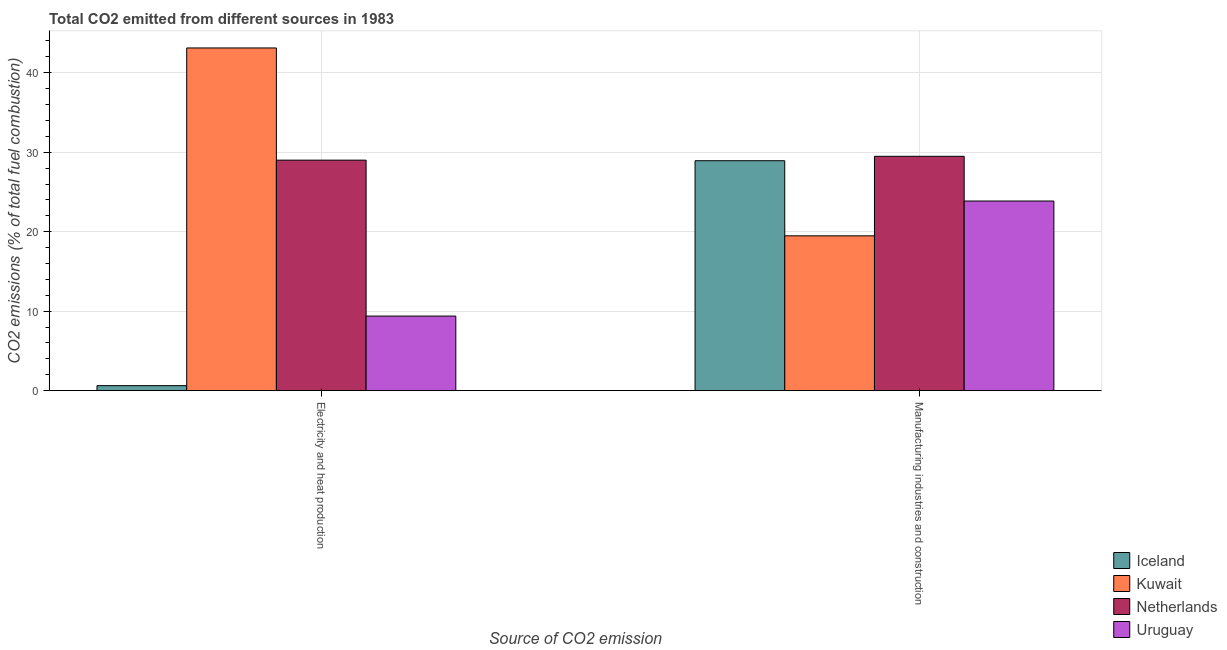Are the number of bars per tick equal to the number of legend labels?
Keep it short and to the point. Yes. Are the number of bars on each tick of the X-axis equal?
Provide a succinct answer. Yes. What is the label of the 2nd group of bars from the left?
Offer a terse response. Manufacturing industries and construction. What is the co2 emissions due to electricity and heat production in Iceland?
Offer a terse response. 0.63. Across all countries, what is the maximum co2 emissions due to manufacturing industries?
Provide a succinct answer. 29.49. Across all countries, what is the minimum co2 emissions due to manufacturing industries?
Ensure brevity in your answer.  19.48. In which country was the co2 emissions due to electricity and heat production maximum?
Your answer should be compact. Kuwait. In which country was the co2 emissions due to electricity and heat production minimum?
Keep it short and to the point. Iceland. What is the total co2 emissions due to electricity and heat production in the graph?
Provide a short and direct response. 82.13. What is the difference between the co2 emissions due to electricity and heat production in Netherlands and that in Iceland?
Ensure brevity in your answer.  28.37. What is the difference between the co2 emissions due to electricity and heat production in Kuwait and the co2 emissions due to manufacturing industries in Iceland?
Give a very brief answer. 14.19. What is the average co2 emissions due to manufacturing industries per country?
Ensure brevity in your answer.  25.44. What is the difference between the co2 emissions due to electricity and heat production and co2 emissions due to manufacturing industries in Netherlands?
Make the answer very short. -0.48. In how many countries, is the co2 emissions due to electricity and heat production greater than 4 %?
Your response must be concise. 3. What is the ratio of the co2 emissions due to electricity and heat production in Iceland to that in Netherlands?
Provide a succinct answer. 0.02. Is the co2 emissions due to manufacturing industries in Uruguay less than that in Kuwait?
Offer a very short reply. No. What does the 2nd bar from the left in Manufacturing industries and construction represents?
Your answer should be compact. Kuwait. What does the 4th bar from the right in Electricity and heat production represents?
Provide a succinct answer. Iceland. How many bars are there?
Your response must be concise. 8. How many countries are there in the graph?
Offer a very short reply. 4. Does the graph contain any zero values?
Keep it short and to the point. No. Does the graph contain grids?
Give a very brief answer. Yes. Where does the legend appear in the graph?
Offer a very short reply. Bottom right. What is the title of the graph?
Your answer should be compact. Total CO2 emitted from different sources in 1983. Does "Luxembourg" appear as one of the legend labels in the graph?
Provide a short and direct response. No. What is the label or title of the X-axis?
Make the answer very short. Source of CO2 emission. What is the label or title of the Y-axis?
Give a very brief answer. CO2 emissions (% of total fuel combustion). What is the CO2 emissions (% of total fuel combustion) of Iceland in Electricity and heat production?
Give a very brief answer. 0.63. What is the CO2 emissions (% of total fuel combustion) of Kuwait in Electricity and heat production?
Make the answer very short. 43.12. What is the CO2 emissions (% of total fuel combustion) of Netherlands in Electricity and heat production?
Make the answer very short. 29. What is the CO2 emissions (% of total fuel combustion) of Uruguay in Electricity and heat production?
Your answer should be very brief. 9.38. What is the CO2 emissions (% of total fuel combustion) of Iceland in Manufacturing industries and construction?
Your answer should be very brief. 28.93. What is the CO2 emissions (% of total fuel combustion) of Kuwait in Manufacturing industries and construction?
Ensure brevity in your answer.  19.48. What is the CO2 emissions (% of total fuel combustion) in Netherlands in Manufacturing industries and construction?
Your response must be concise. 29.49. What is the CO2 emissions (% of total fuel combustion) of Uruguay in Manufacturing industries and construction?
Provide a short and direct response. 23.86. Across all Source of CO2 emission, what is the maximum CO2 emissions (% of total fuel combustion) of Iceland?
Offer a very short reply. 28.93. Across all Source of CO2 emission, what is the maximum CO2 emissions (% of total fuel combustion) in Kuwait?
Give a very brief answer. 43.12. Across all Source of CO2 emission, what is the maximum CO2 emissions (% of total fuel combustion) in Netherlands?
Your answer should be very brief. 29.49. Across all Source of CO2 emission, what is the maximum CO2 emissions (% of total fuel combustion) of Uruguay?
Offer a very short reply. 23.86. Across all Source of CO2 emission, what is the minimum CO2 emissions (% of total fuel combustion) in Iceland?
Your answer should be very brief. 0.63. Across all Source of CO2 emission, what is the minimum CO2 emissions (% of total fuel combustion) in Kuwait?
Give a very brief answer. 19.48. Across all Source of CO2 emission, what is the minimum CO2 emissions (% of total fuel combustion) of Netherlands?
Ensure brevity in your answer.  29. Across all Source of CO2 emission, what is the minimum CO2 emissions (% of total fuel combustion) in Uruguay?
Make the answer very short. 9.38. What is the total CO2 emissions (% of total fuel combustion) in Iceland in the graph?
Make the answer very short. 29.56. What is the total CO2 emissions (% of total fuel combustion) of Kuwait in the graph?
Provide a succinct answer. 62.6. What is the total CO2 emissions (% of total fuel combustion) of Netherlands in the graph?
Provide a succinct answer. 58.49. What is the total CO2 emissions (% of total fuel combustion) in Uruguay in the graph?
Your answer should be very brief. 33.24. What is the difference between the CO2 emissions (% of total fuel combustion) of Iceland in Electricity and heat production and that in Manufacturing industries and construction?
Your answer should be very brief. -28.3. What is the difference between the CO2 emissions (% of total fuel combustion) of Kuwait in Electricity and heat production and that in Manufacturing industries and construction?
Your response must be concise. 23.64. What is the difference between the CO2 emissions (% of total fuel combustion) of Netherlands in Electricity and heat production and that in Manufacturing industries and construction?
Offer a terse response. -0.48. What is the difference between the CO2 emissions (% of total fuel combustion) in Uruguay in Electricity and heat production and that in Manufacturing industries and construction?
Provide a short and direct response. -14.48. What is the difference between the CO2 emissions (% of total fuel combustion) in Iceland in Electricity and heat production and the CO2 emissions (% of total fuel combustion) in Kuwait in Manufacturing industries and construction?
Offer a very short reply. -18.85. What is the difference between the CO2 emissions (% of total fuel combustion) of Iceland in Electricity and heat production and the CO2 emissions (% of total fuel combustion) of Netherlands in Manufacturing industries and construction?
Keep it short and to the point. -28.86. What is the difference between the CO2 emissions (% of total fuel combustion) in Iceland in Electricity and heat production and the CO2 emissions (% of total fuel combustion) in Uruguay in Manufacturing industries and construction?
Offer a terse response. -23.23. What is the difference between the CO2 emissions (% of total fuel combustion) in Kuwait in Electricity and heat production and the CO2 emissions (% of total fuel combustion) in Netherlands in Manufacturing industries and construction?
Offer a very short reply. 13.63. What is the difference between the CO2 emissions (% of total fuel combustion) of Kuwait in Electricity and heat production and the CO2 emissions (% of total fuel combustion) of Uruguay in Manufacturing industries and construction?
Provide a short and direct response. 19.26. What is the difference between the CO2 emissions (% of total fuel combustion) of Netherlands in Electricity and heat production and the CO2 emissions (% of total fuel combustion) of Uruguay in Manufacturing industries and construction?
Ensure brevity in your answer.  5.14. What is the average CO2 emissions (% of total fuel combustion) in Iceland per Source of CO2 emission?
Ensure brevity in your answer.  14.78. What is the average CO2 emissions (% of total fuel combustion) in Kuwait per Source of CO2 emission?
Make the answer very short. 31.3. What is the average CO2 emissions (% of total fuel combustion) of Netherlands per Source of CO2 emission?
Keep it short and to the point. 29.25. What is the average CO2 emissions (% of total fuel combustion) of Uruguay per Source of CO2 emission?
Your answer should be compact. 16.62. What is the difference between the CO2 emissions (% of total fuel combustion) in Iceland and CO2 emissions (% of total fuel combustion) in Kuwait in Electricity and heat production?
Your answer should be very brief. -42.49. What is the difference between the CO2 emissions (% of total fuel combustion) in Iceland and CO2 emissions (% of total fuel combustion) in Netherlands in Electricity and heat production?
Offer a terse response. -28.37. What is the difference between the CO2 emissions (% of total fuel combustion) in Iceland and CO2 emissions (% of total fuel combustion) in Uruguay in Electricity and heat production?
Give a very brief answer. -8.75. What is the difference between the CO2 emissions (% of total fuel combustion) of Kuwait and CO2 emissions (% of total fuel combustion) of Netherlands in Electricity and heat production?
Your answer should be compact. 14.12. What is the difference between the CO2 emissions (% of total fuel combustion) of Kuwait and CO2 emissions (% of total fuel combustion) of Uruguay in Electricity and heat production?
Give a very brief answer. 33.74. What is the difference between the CO2 emissions (% of total fuel combustion) of Netherlands and CO2 emissions (% of total fuel combustion) of Uruguay in Electricity and heat production?
Keep it short and to the point. 19.62. What is the difference between the CO2 emissions (% of total fuel combustion) in Iceland and CO2 emissions (% of total fuel combustion) in Kuwait in Manufacturing industries and construction?
Keep it short and to the point. 9.45. What is the difference between the CO2 emissions (% of total fuel combustion) in Iceland and CO2 emissions (% of total fuel combustion) in Netherlands in Manufacturing industries and construction?
Your answer should be very brief. -0.56. What is the difference between the CO2 emissions (% of total fuel combustion) of Iceland and CO2 emissions (% of total fuel combustion) of Uruguay in Manufacturing industries and construction?
Provide a succinct answer. 5.07. What is the difference between the CO2 emissions (% of total fuel combustion) of Kuwait and CO2 emissions (% of total fuel combustion) of Netherlands in Manufacturing industries and construction?
Your answer should be very brief. -10.01. What is the difference between the CO2 emissions (% of total fuel combustion) in Kuwait and CO2 emissions (% of total fuel combustion) in Uruguay in Manufacturing industries and construction?
Provide a short and direct response. -4.38. What is the difference between the CO2 emissions (% of total fuel combustion) in Netherlands and CO2 emissions (% of total fuel combustion) in Uruguay in Manufacturing industries and construction?
Ensure brevity in your answer.  5.63. What is the ratio of the CO2 emissions (% of total fuel combustion) in Iceland in Electricity and heat production to that in Manufacturing industries and construction?
Your response must be concise. 0.02. What is the ratio of the CO2 emissions (% of total fuel combustion) in Kuwait in Electricity and heat production to that in Manufacturing industries and construction?
Provide a succinct answer. 2.21. What is the ratio of the CO2 emissions (% of total fuel combustion) in Netherlands in Electricity and heat production to that in Manufacturing industries and construction?
Your response must be concise. 0.98. What is the ratio of the CO2 emissions (% of total fuel combustion) in Uruguay in Electricity and heat production to that in Manufacturing industries and construction?
Offer a very short reply. 0.39. What is the difference between the highest and the second highest CO2 emissions (% of total fuel combustion) of Iceland?
Make the answer very short. 28.3. What is the difference between the highest and the second highest CO2 emissions (% of total fuel combustion) in Kuwait?
Offer a very short reply. 23.64. What is the difference between the highest and the second highest CO2 emissions (% of total fuel combustion) in Netherlands?
Keep it short and to the point. 0.48. What is the difference between the highest and the second highest CO2 emissions (% of total fuel combustion) of Uruguay?
Your response must be concise. 14.48. What is the difference between the highest and the lowest CO2 emissions (% of total fuel combustion) of Iceland?
Your response must be concise. 28.3. What is the difference between the highest and the lowest CO2 emissions (% of total fuel combustion) of Kuwait?
Make the answer very short. 23.64. What is the difference between the highest and the lowest CO2 emissions (% of total fuel combustion) in Netherlands?
Make the answer very short. 0.48. What is the difference between the highest and the lowest CO2 emissions (% of total fuel combustion) of Uruguay?
Provide a short and direct response. 14.48. 